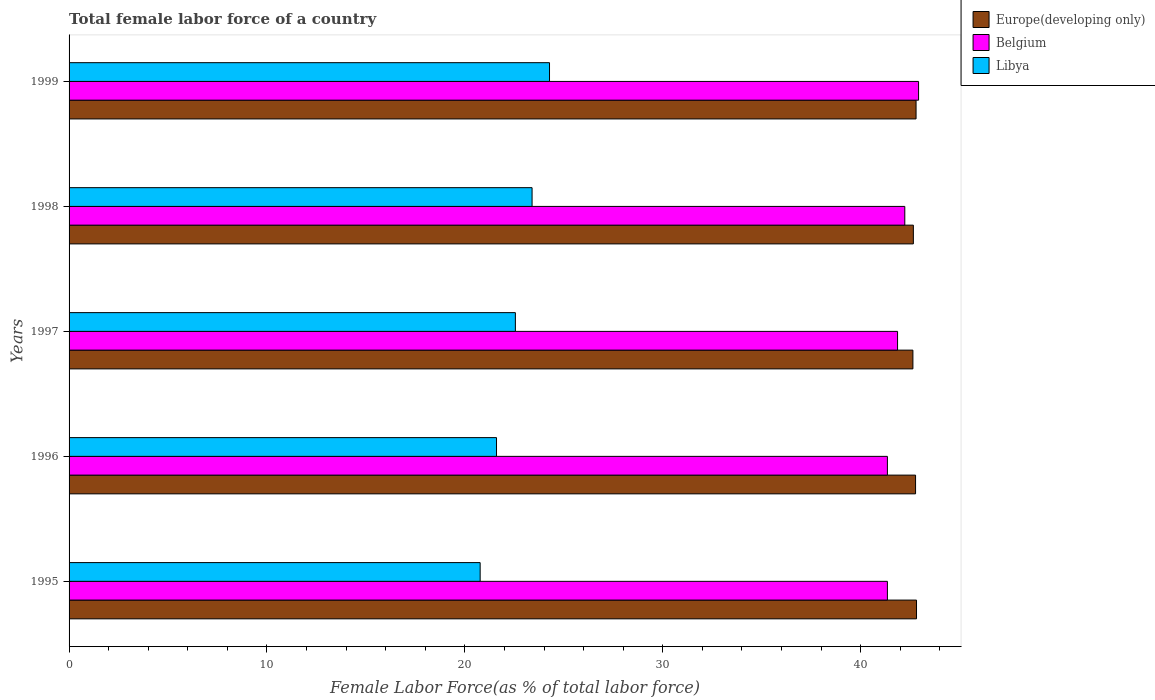Are the number of bars per tick equal to the number of legend labels?
Make the answer very short. Yes. How many bars are there on the 1st tick from the bottom?
Your answer should be very brief. 3. In how many cases, is the number of bars for a given year not equal to the number of legend labels?
Offer a very short reply. 0. What is the percentage of female labor force in Belgium in 1995?
Provide a short and direct response. 41.35. Across all years, what is the maximum percentage of female labor force in Belgium?
Your answer should be compact. 42.93. Across all years, what is the minimum percentage of female labor force in Belgium?
Your response must be concise. 41.35. What is the total percentage of female labor force in Libya in the graph?
Give a very brief answer. 112.6. What is the difference between the percentage of female labor force in Libya in 1995 and that in 1998?
Offer a terse response. -2.62. What is the difference between the percentage of female labor force in Europe(developing only) in 1996 and the percentage of female labor force in Libya in 1998?
Your response must be concise. 19.38. What is the average percentage of female labor force in Europe(developing only) per year?
Keep it short and to the point. 42.74. In the year 1998, what is the difference between the percentage of female labor force in Belgium and percentage of female labor force in Libya?
Keep it short and to the point. 18.83. What is the ratio of the percentage of female labor force in Belgium in 1995 to that in 1997?
Make the answer very short. 0.99. Is the percentage of female labor force in Libya in 1997 less than that in 1998?
Keep it short and to the point. Yes. What is the difference between the highest and the second highest percentage of female labor force in Belgium?
Provide a short and direct response. 0.7. What is the difference between the highest and the lowest percentage of female labor force in Europe(developing only)?
Ensure brevity in your answer.  0.18. In how many years, is the percentage of female labor force in Libya greater than the average percentage of female labor force in Libya taken over all years?
Your response must be concise. 3. What does the 2nd bar from the top in 1999 represents?
Your response must be concise. Belgium. What does the 2nd bar from the bottom in 1995 represents?
Offer a very short reply. Belgium. How many bars are there?
Give a very brief answer. 15. Are all the bars in the graph horizontal?
Provide a succinct answer. Yes. How many years are there in the graph?
Give a very brief answer. 5. What is the difference between two consecutive major ticks on the X-axis?
Make the answer very short. 10. Are the values on the major ticks of X-axis written in scientific E-notation?
Offer a terse response. No. Does the graph contain any zero values?
Your answer should be compact. No. What is the title of the graph?
Keep it short and to the point. Total female labor force of a country. Does "Spain" appear as one of the legend labels in the graph?
Your response must be concise. No. What is the label or title of the X-axis?
Offer a terse response. Female Labor Force(as % of total labor force). What is the Female Labor Force(as % of total labor force) of Europe(developing only) in 1995?
Your response must be concise. 42.82. What is the Female Labor Force(as % of total labor force) in Belgium in 1995?
Your response must be concise. 41.35. What is the Female Labor Force(as % of total labor force) of Libya in 1995?
Ensure brevity in your answer.  20.77. What is the Female Labor Force(as % of total labor force) in Europe(developing only) in 1996?
Ensure brevity in your answer.  42.78. What is the Female Labor Force(as % of total labor force) in Belgium in 1996?
Offer a terse response. 41.35. What is the Female Labor Force(as % of total labor force) of Libya in 1996?
Provide a succinct answer. 21.6. What is the Female Labor Force(as % of total labor force) of Europe(developing only) in 1997?
Your answer should be very brief. 42.64. What is the Female Labor Force(as % of total labor force) in Belgium in 1997?
Provide a succinct answer. 41.87. What is the Female Labor Force(as % of total labor force) of Libya in 1997?
Make the answer very short. 22.55. What is the Female Labor Force(as % of total labor force) of Europe(developing only) in 1998?
Ensure brevity in your answer.  42.66. What is the Female Labor Force(as % of total labor force) of Belgium in 1998?
Give a very brief answer. 42.23. What is the Female Labor Force(as % of total labor force) in Libya in 1998?
Keep it short and to the point. 23.4. What is the Female Labor Force(as % of total labor force) in Europe(developing only) in 1999?
Your response must be concise. 42.8. What is the Female Labor Force(as % of total labor force) of Belgium in 1999?
Give a very brief answer. 42.93. What is the Female Labor Force(as % of total labor force) in Libya in 1999?
Provide a succinct answer. 24.28. Across all years, what is the maximum Female Labor Force(as % of total labor force) in Europe(developing only)?
Your response must be concise. 42.82. Across all years, what is the maximum Female Labor Force(as % of total labor force) of Belgium?
Your response must be concise. 42.93. Across all years, what is the maximum Female Labor Force(as % of total labor force) in Libya?
Give a very brief answer. 24.28. Across all years, what is the minimum Female Labor Force(as % of total labor force) in Europe(developing only)?
Ensure brevity in your answer.  42.64. Across all years, what is the minimum Female Labor Force(as % of total labor force) in Belgium?
Provide a succinct answer. 41.35. Across all years, what is the minimum Female Labor Force(as % of total labor force) in Libya?
Your answer should be compact. 20.77. What is the total Female Labor Force(as % of total labor force) in Europe(developing only) in the graph?
Offer a very short reply. 213.71. What is the total Female Labor Force(as % of total labor force) of Belgium in the graph?
Your answer should be compact. 209.73. What is the total Female Labor Force(as % of total labor force) in Libya in the graph?
Offer a terse response. 112.6. What is the difference between the Female Labor Force(as % of total labor force) in Europe(developing only) in 1995 and that in 1996?
Keep it short and to the point. 0.05. What is the difference between the Female Labor Force(as % of total labor force) of Belgium in 1995 and that in 1996?
Make the answer very short. 0. What is the difference between the Female Labor Force(as % of total labor force) of Libya in 1995 and that in 1996?
Make the answer very short. -0.83. What is the difference between the Female Labor Force(as % of total labor force) of Europe(developing only) in 1995 and that in 1997?
Your answer should be very brief. 0.18. What is the difference between the Female Labor Force(as % of total labor force) of Belgium in 1995 and that in 1997?
Your answer should be compact. -0.51. What is the difference between the Female Labor Force(as % of total labor force) in Libya in 1995 and that in 1997?
Provide a succinct answer. -1.78. What is the difference between the Female Labor Force(as % of total labor force) in Europe(developing only) in 1995 and that in 1998?
Provide a short and direct response. 0.16. What is the difference between the Female Labor Force(as % of total labor force) in Belgium in 1995 and that in 1998?
Give a very brief answer. -0.88. What is the difference between the Female Labor Force(as % of total labor force) in Libya in 1995 and that in 1998?
Make the answer very short. -2.62. What is the difference between the Female Labor Force(as % of total labor force) of Europe(developing only) in 1995 and that in 1999?
Give a very brief answer. 0.02. What is the difference between the Female Labor Force(as % of total labor force) of Belgium in 1995 and that in 1999?
Provide a short and direct response. -1.58. What is the difference between the Female Labor Force(as % of total labor force) in Libya in 1995 and that in 1999?
Offer a terse response. -3.51. What is the difference between the Female Labor Force(as % of total labor force) in Europe(developing only) in 1996 and that in 1997?
Keep it short and to the point. 0.13. What is the difference between the Female Labor Force(as % of total labor force) in Belgium in 1996 and that in 1997?
Your response must be concise. -0.51. What is the difference between the Female Labor Force(as % of total labor force) in Libya in 1996 and that in 1997?
Your response must be concise. -0.95. What is the difference between the Female Labor Force(as % of total labor force) in Europe(developing only) in 1996 and that in 1998?
Keep it short and to the point. 0.11. What is the difference between the Female Labor Force(as % of total labor force) of Belgium in 1996 and that in 1998?
Keep it short and to the point. -0.88. What is the difference between the Female Labor Force(as % of total labor force) of Libya in 1996 and that in 1998?
Offer a very short reply. -1.8. What is the difference between the Female Labor Force(as % of total labor force) of Europe(developing only) in 1996 and that in 1999?
Make the answer very short. -0.03. What is the difference between the Female Labor Force(as % of total labor force) in Belgium in 1996 and that in 1999?
Provide a succinct answer. -1.58. What is the difference between the Female Labor Force(as % of total labor force) in Libya in 1996 and that in 1999?
Your answer should be compact. -2.68. What is the difference between the Female Labor Force(as % of total labor force) of Europe(developing only) in 1997 and that in 1998?
Make the answer very short. -0.02. What is the difference between the Female Labor Force(as % of total labor force) in Belgium in 1997 and that in 1998?
Give a very brief answer. -0.36. What is the difference between the Female Labor Force(as % of total labor force) in Libya in 1997 and that in 1998?
Ensure brevity in your answer.  -0.84. What is the difference between the Female Labor Force(as % of total labor force) in Europe(developing only) in 1997 and that in 1999?
Ensure brevity in your answer.  -0.16. What is the difference between the Female Labor Force(as % of total labor force) in Belgium in 1997 and that in 1999?
Provide a succinct answer. -1.06. What is the difference between the Female Labor Force(as % of total labor force) in Libya in 1997 and that in 1999?
Make the answer very short. -1.73. What is the difference between the Female Labor Force(as % of total labor force) in Europe(developing only) in 1998 and that in 1999?
Provide a succinct answer. -0.14. What is the difference between the Female Labor Force(as % of total labor force) in Belgium in 1998 and that in 1999?
Provide a short and direct response. -0.7. What is the difference between the Female Labor Force(as % of total labor force) of Libya in 1998 and that in 1999?
Your answer should be compact. -0.88. What is the difference between the Female Labor Force(as % of total labor force) in Europe(developing only) in 1995 and the Female Labor Force(as % of total labor force) in Belgium in 1996?
Offer a terse response. 1.47. What is the difference between the Female Labor Force(as % of total labor force) in Europe(developing only) in 1995 and the Female Labor Force(as % of total labor force) in Libya in 1996?
Give a very brief answer. 21.22. What is the difference between the Female Labor Force(as % of total labor force) in Belgium in 1995 and the Female Labor Force(as % of total labor force) in Libya in 1996?
Offer a terse response. 19.75. What is the difference between the Female Labor Force(as % of total labor force) in Europe(developing only) in 1995 and the Female Labor Force(as % of total labor force) in Belgium in 1997?
Provide a short and direct response. 0.96. What is the difference between the Female Labor Force(as % of total labor force) of Europe(developing only) in 1995 and the Female Labor Force(as % of total labor force) of Libya in 1997?
Provide a short and direct response. 20.27. What is the difference between the Female Labor Force(as % of total labor force) in Belgium in 1995 and the Female Labor Force(as % of total labor force) in Libya in 1997?
Give a very brief answer. 18.8. What is the difference between the Female Labor Force(as % of total labor force) in Europe(developing only) in 1995 and the Female Labor Force(as % of total labor force) in Belgium in 1998?
Keep it short and to the point. 0.59. What is the difference between the Female Labor Force(as % of total labor force) of Europe(developing only) in 1995 and the Female Labor Force(as % of total labor force) of Libya in 1998?
Provide a succinct answer. 19.43. What is the difference between the Female Labor Force(as % of total labor force) of Belgium in 1995 and the Female Labor Force(as % of total labor force) of Libya in 1998?
Provide a short and direct response. 17.96. What is the difference between the Female Labor Force(as % of total labor force) of Europe(developing only) in 1995 and the Female Labor Force(as % of total labor force) of Belgium in 1999?
Your answer should be compact. -0.1. What is the difference between the Female Labor Force(as % of total labor force) in Europe(developing only) in 1995 and the Female Labor Force(as % of total labor force) in Libya in 1999?
Keep it short and to the point. 18.55. What is the difference between the Female Labor Force(as % of total labor force) in Belgium in 1995 and the Female Labor Force(as % of total labor force) in Libya in 1999?
Your answer should be very brief. 17.07. What is the difference between the Female Labor Force(as % of total labor force) in Europe(developing only) in 1996 and the Female Labor Force(as % of total labor force) in Belgium in 1997?
Offer a very short reply. 0.91. What is the difference between the Female Labor Force(as % of total labor force) in Europe(developing only) in 1996 and the Female Labor Force(as % of total labor force) in Libya in 1997?
Offer a terse response. 20.22. What is the difference between the Female Labor Force(as % of total labor force) in Belgium in 1996 and the Female Labor Force(as % of total labor force) in Libya in 1997?
Offer a terse response. 18.8. What is the difference between the Female Labor Force(as % of total labor force) of Europe(developing only) in 1996 and the Female Labor Force(as % of total labor force) of Belgium in 1998?
Make the answer very short. 0.54. What is the difference between the Female Labor Force(as % of total labor force) of Europe(developing only) in 1996 and the Female Labor Force(as % of total labor force) of Libya in 1998?
Offer a very short reply. 19.38. What is the difference between the Female Labor Force(as % of total labor force) in Belgium in 1996 and the Female Labor Force(as % of total labor force) in Libya in 1998?
Your answer should be very brief. 17.96. What is the difference between the Female Labor Force(as % of total labor force) of Europe(developing only) in 1996 and the Female Labor Force(as % of total labor force) of Belgium in 1999?
Provide a succinct answer. -0.15. What is the difference between the Female Labor Force(as % of total labor force) of Europe(developing only) in 1996 and the Female Labor Force(as % of total labor force) of Libya in 1999?
Make the answer very short. 18.5. What is the difference between the Female Labor Force(as % of total labor force) of Belgium in 1996 and the Female Labor Force(as % of total labor force) of Libya in 1999?
Provide a short and direct response. 17.07. What is the difference between the Female Labor Force(as % of total labor force) of Europe(developing only) in 1997 and the Female Labor Force(as % of total labor force) of Belgium in 1998?
Keep it short and to the point. 0.41. What is the difference between the Female Labor Force(as % of total labor force) of Europe(developing only) in 1997 and the Female Labor Force(as % of total labor force) of Libya in 1998?
Your response must be concise. 19.24. What is the difference between the Female Labor Force(as % of total labor force) in Belgium in 1997 and the Female Labor Force(as % of total labor force) in Libya in 1998?
Give a very brief answer. 18.47. What is the difference between the Female Labor Force(as % of total labor force) in Europe(developing only) in 1997 and the Female Labor Force(as % of total labor force) in Belgium in 1999?
Provide a succinct answer. -0.29. What is the difference between the Female Labor Force(as % of total labor force) in Europe(developing only) in 1997 and the Female Labor Force(as % of total labor force) in Libya in 1999?
Your answer should be very brief. 18.36. What is the difference between the Female Labor Force(as % of total labor force) in Belgium in 1997 and the Female Labor Force(as % of total labor force) in Libya in 1999?
Your response must be concise. 17.59. What is the difference between the Female Labor Force(as % of total labor force) of Europe(developing only) in 1998 and the Female Labor Force(as % of total labor force) of Belgium in 1999?
Your answer should be very brief. -0.26. What is the difference between the Female Labor Force(as % of total labor force) of Europe(developing only) in 1998 and the Female Labor Force(as % of total labor force) of Libya in 1999?
Offer a very short reply. 18.39. What is the difference between the Female Labor Force(as % of total labor force) in Belgium in 1998 and the Female Labor Force(as % of total labor force) in Libya in 1999?
Provide a short and direct response. 17.95. What is the average Female Labor Force(as % of total labor force) in Europe(developing only) per year?
Ensure brevity in your answer.  42.74. What is the average Female Labor Force(as % of total labor force) in Belgium per year?
Keep it short and to the point. 41.95. What is the average Female Labor Force(as % of total labor force) in Libya per year?
Provide a succinct answer. 22.52. In the year 1995, what is the difference between the Female Labor Force(as % of total labor force) in Europe(developing only) and Female Labor Force(as % of total labor force) in Belgium?
Provide a succinct answer. 1.47. In the year 1995, what is the difference between the Female Labor Force(as % of total labor force) in Europe(developing only) and Female Labor Force(as % of total labor force) in Libya?
Your answer should be very brief. 22.05. In the year 1995, what is the difference between the Female Labor Force(as % of total labor force) in Belgium and Female Labor Force(as % of total labor force) in Libya?
Your response must be concise. 20.58. In the year 1996, what is the difference between the Female Labor Force(as % of total labor force) of Europe(developing only) and Female Labor Force(as % of total labor force) of Belgium?
Make the answer very short. 1.42. In the year 1996, what is the difference between the Female Labor Force(as % of total labor force) in Europe(developing only) and Female Labor Force(as % of total labor force) in Libya?
Keep it short and to the point. 21.18. In the year 1996, what is the difference between the Female Labor Force(as % of total labor force) of Belgium and Female Labor Force(as % of total labor force) of Libya?
Provide a short and direct response. 19.75. In the year 1997, what is the difference between the Female Labor Force(as % of total labor force) of Europe(developing only) and Female Labor Force(as % of total labor force) of Belgium?
Offer a terse response. 0.78. In the year 1997, what is the difference between the Female Labor Force(as % of total labor force) in Europe(developing only) and Female Labor Force(as % of total labor force) in Libya?
Give a very brief answer. 20.09. In the year 1997, what is the difference between the Female Labor Force(as % of total labor force) in Belgium and Female Labor Force(as % of total labor force) in Libya?
Ensure brevity in your answer.  19.31. In the year 1998, what is the difference between the Female Labor Force(as % of total labor force) in Europe(developing only) and Female Labor Force(as % of total labor force) in Belgium?
Your answer should be compact. 0.43. In the year 1998, what is the difference between the Female Labor Force(as % of total labor force) in Europe(developing only) and Female Labor Force(as % of total labor force) in Libya?
Ensure brevity in your answer.  19.27. In the year 1998, what is the difference between the Female Labor Force(as % of total labor force) of Belgium and Female Labor Force(as % of total labor force) of Libya?
Keep it short and to the point. 18.83. In the year 1999, what is the difference between the Female Labor Force(as % of total labor force) in Europe(developing only) and Female Labor Force(as % of total labor force) in Belgium?
Your response must be concise. -0.13. In the year 1999, what is the difference between the Female Labor Force(as % of total labor force) in Europe(developing only) and Female Labor Force(as % of total labor force) in Libya?
Your answer should be compact. 18.52. In the year 1999, what is the difference between the Female Labor Force(as % of total labor force) in Belgium and Female Labor Force(as % of total labor force) in Libya?
Offer a very short reply. 18.65. What is the ratio of the Female Labor Force(as % of total labor force) of Europe(developing only) in 1995 to that in 1996?
Ensure brevity in your answer.  1. What is the ratio of the Female Labor Force(as % of total labor force) of Belgium in 1995 to that in 1996?
Ensure brevity in your answer.  1. What is the ratio of the Female Labor Force(as % of total labor force) of Libya in 1995 to that in 1996?
Offer a terse response. 0.96. What is the ratio of the Female Labor Force(as % of total labor force) of Belgium in 1995 to that in 1997?
Offer a terse response. 0.99. What is the ratio of the Female Labor Force(as % of total labor force) of Libya in 1995 to that in 1997?
Provide a short and direct response. 0.92. What is the ratio of the Female Labor Force(as % of total labor force) of Belgium in 1995 to that in 1998?
Your answer should be very brief. 0.98. What is the ratio of the Female Labor Force(as % of total labor force) of Libya in 1995 to that in 1998?
Your answer should be very brief. 0.89. What is the ratio of the Female Labor Force(as % of total labor force) of Europe(developing only) in 1995 to that in 1999?
Make the answer very short. 1. What is the ratio of the Female Labor Force(as % of total labor force) of Belgium in 1995 to that in 1999?
Give a very brief answer. 0.96. What is the ratio of the Female Labor Force(as % of total labor force) in Libya in 1995 to that in 1999?
Make the answer very short. 0.86. What is the ratio of the Female Labor Force(as % of total labor force) in Europe(developing only) in 1996 to that in 1997?
Ensure brevity in your answer.  1. What is the ratio of the Female Labor Force(as % of total labor force) of Libya in 1996 to that in 1997?
Provide a succinct answer. 0.96. What is the ratio of the Female Labor Force(as % of total labor force) of Europe(developing only) in 1996 to that in 1998?
Offer a terse response. 1. What is the ratio of the Female Labor Force(as % of total labor force) of Belgium in 1996 to that in 1998?
Your answer should be compact. 0.98. What is the ratio of the Female Labor Force(as % of total labor force) in Libya in 1996 to that in 1998?
Provide a succinct answer. 0.92. What is the ratio of the Female Labor Force(as % of total labor force) in Europe(developing only) in 1996 to that in 1999?
Keep it short and to the point. 1. What is the ratio of the Female Labor Force(as % of total labor force) in Belgium in 1996 to that in 1999?
Make the answer very short. 0.96. What is the ratio of the Female Labor Force(as % of total labor force) of Libya in 1996 to that in 1999?
Give a very brief answer. 0.89. What is the ratio of the Female Labor Force(as % of total labor force) of Europe(developing only) in 1997 to that in 1998?
Offer a very short reply. 1. What is the ratio of the Female Labor Force(as % of total labor force) in Libya in 1997 to that in 1998?
Offer a terse response. 0.96. What is the ratio of the Female Labor Force(as % of total labor force) in Europe(developing only) in 1997 to that in 1999?
Your response must be concise. 1. What is the ratio of the Female Labor Force(as % of total labor force) of Belgium in 1997 to that in 1999?
Your response must be concise. 0.98. What is the ratio of the Female Labor Force(as % of total labor force) in Libya in 1997 to that in 1999?
Make the answer very short. 0.93. What is the ratio of the Female Labor Force(as % of total labor force) in Europe(developing only) in 1998 to that in 1999?
Offer a terse response. 1. What is the ratio of the Female Labor Force(as % of total labor force) in Belgium in 1998 to that in 1999?
Provide a short and direct response. 0.98. What is the ratio of the Female Labor Force(as % of total labor force) in Libya in 1998 to that in 1999?
Ensure brevity in your answer.  0.96. What is the difference between the highest and the second highest Female Labor Force(as % of total labor force) of Europe(developing only)?
Provide a succinct answer. 0.02. What is the difference between the highest and the second highest Female Labor Force(as % of total labor force) of Belgium?
Ensure brevity in your answer.  0.7. What is the difference between the highest and the second highest Female Labor Force(as % of total labor force) in Libya?
Give a very brief answer. 0.88. What is the difference between the highest and the lowest Female Labor Force(as % of total labor force) in Europe(developing only)?
Make the answer very short. 0.18. What is the difference between the highest and the lowest Female Labor Force(as % of total labor force) in Belgium?
Your answer should be compact. 1.58. What is the difference between the highest and the lowest Female Labor Force(as % of total labor force) of Libya?
Your answer should be compact. 3.51. 